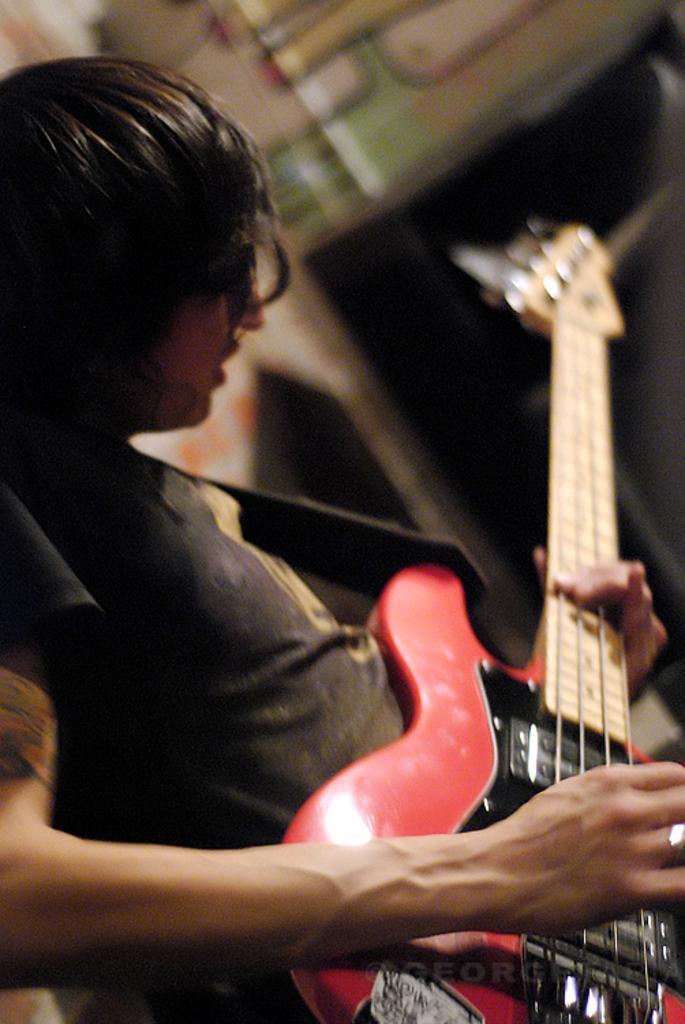Describe this image in one or two sentences. In this picture I can see this a person holding a guitar and playing it, he is looking at it. The backdrop is blurred. 